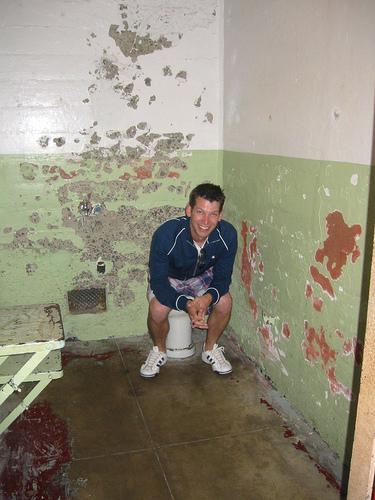Question: why is the man sitting?
Choices:
A. Pretending to read.
B. Pretending to use the bathroom.
C. To rest.
D. To relax.
Answer with the letter. Answer: B Question: who is on the toilet?
Choices:
A. A woman.
B. A boy.
C. A man.
D. A girl.
Answer with the letter. Answer: C 